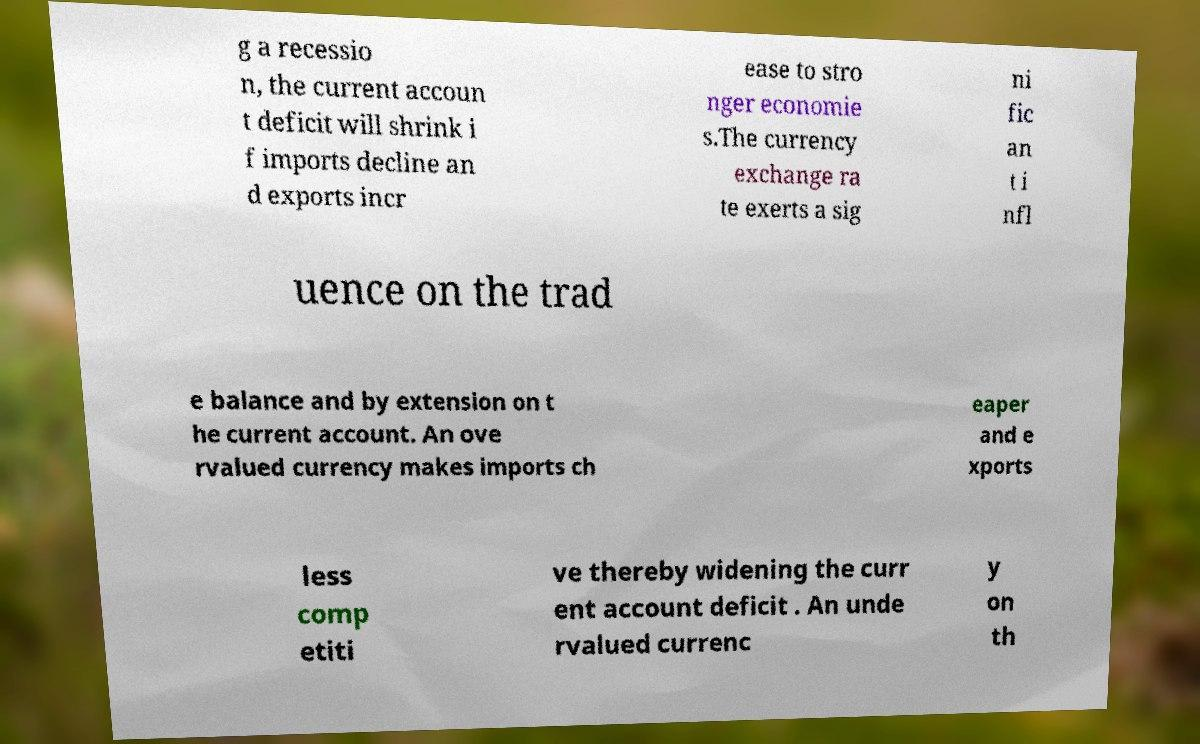There's text embedded in this image that I need extracted. Can you transcribe it verbatim? g a recessio n, the current accoun t deficit will shrink i f imports decline an d exports incr ease to stro nger economie s.The currency exchange ra te exerts a sig ni fic an t i nfl uence on the trad e balance and by extension on t he current account. An ove rvalued currency makes imports ch eaper and e xports less comp etiti ve thereby widening the curr ent account deficit . An unde rvalued currenc y on th 